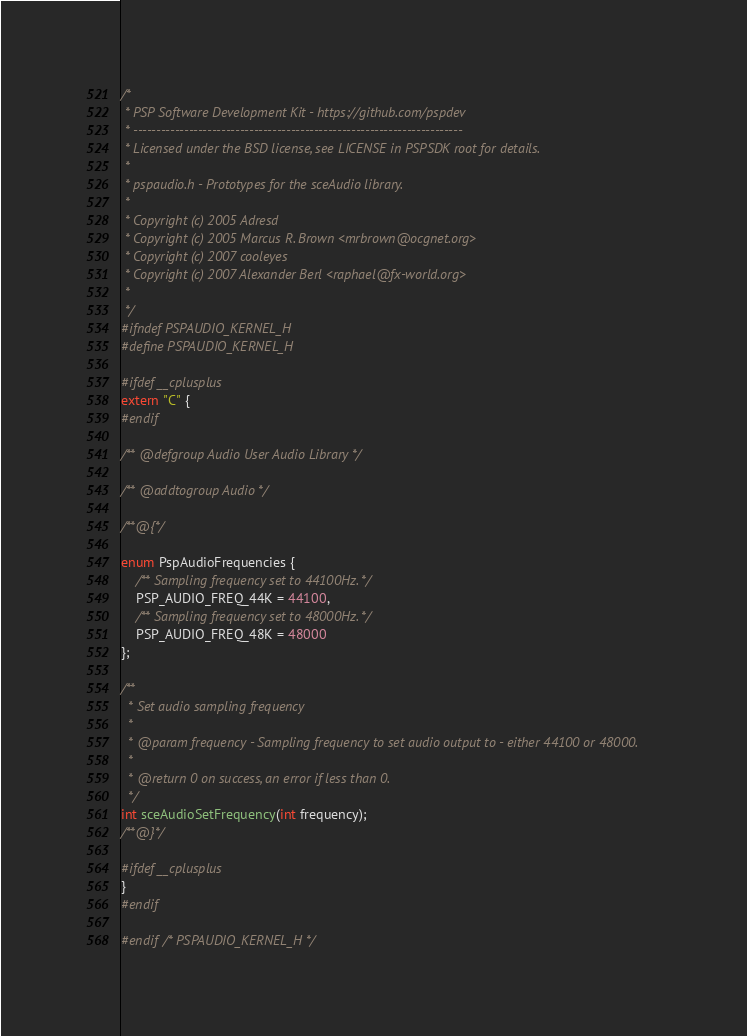Convert code to text. <code><loc_0><loc_0><loc_500><loc_500><_C_>/*
 * PSP Software Development Kit - https://github.com/pspdev
 * -----------------------------------------------------------------------
 * Licensed under the BSD license, see LICENSE in PSPSDK root for details.
 *
 * pspaudio.h - Prototypes for the sceAudio library.
 *
 * Copyright (c) 2005 Adresd
 * Copyright (c) 2005 Marcus R. Brown <mrbrown@ocgnet.org>
 * Copyright (c) 2007 cooleyes
 * Copyright (c) 2007 Alexander Berl <raphael@fx-world.org>
 *
 */
#ifndef PSPAUDIO_KERNEL_H
#define PSPAUDIO_KERNEL_H

#ifdef __cplusplus
extern "C" {
#endif

/** @defgroup Audio User Audio Library */

/** @addtogroup Audio */

/**@{*/

enum PspAudioFrequencies {
    /** Sampling frequency set to 44100Hz. */
    PSP_AUDIO_FREQ_44K = 44100,
    /** Sampling frequency set to 48000Hz. */
    PSP_AUDIO_FREQ_48K = 48000
};

/**
  * Set audio sampling frequency
  *
  * @param frequency - Sampling frequency to set audio output to - either 44100 or 48000.
  *
  * @return 0 on success, an error if less than 0.
  */
int sceAudioSetFrequency(int frequency);
/**@}*/

#ifdef __cplusplus
}
#endif

#endif /* PSPAUDIO_KERNEL_H */
</code> 